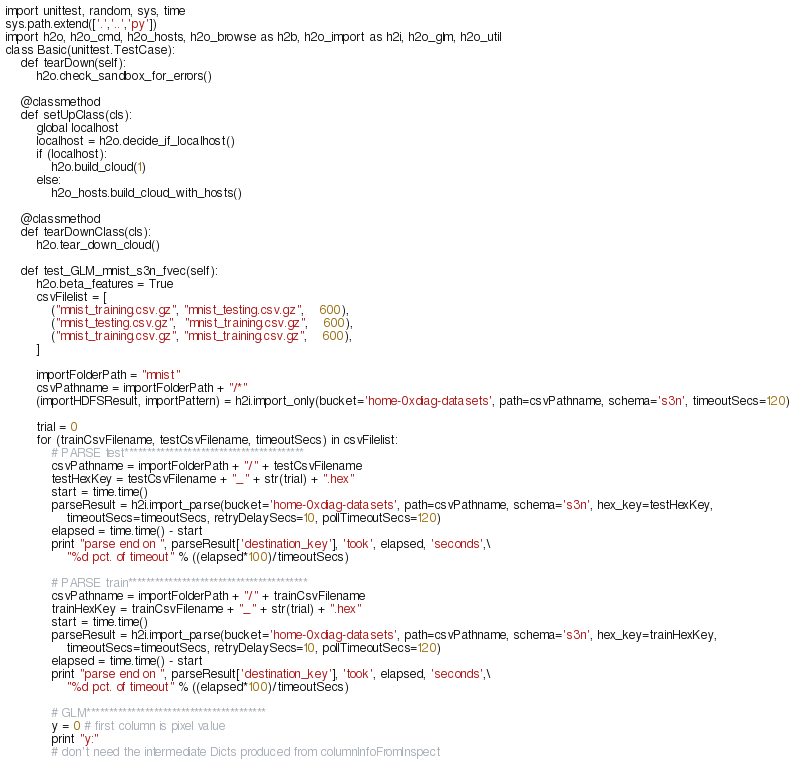Convert code to text. <code><loc_0><loc_0><loc_500><loc_500><_Python_>import unittest, random, sys, time
sys.path.extend(['.','..','py'])
import h2o, h2o_cmd, h2o_hosts, h2o_browse as h2b, h2o_import as h2i, h2o_glm, h2o_util
class Basic(unittest.TestCase):
    def tearDown(self):
        h2o.check_sandbox_for_errors()

    @classmethod
    def setUpClass(cls):
        global localhost
        localhost = h2o.decide_if_localhost()
        if (localhost):
            h2o.build_cloud(1)
        else:
            h2o_hosts.build_cloud_with_hosts()

    @classmethod
    def tearDownClass(cls):
        h2o.tear_down_cloud()

    def test_GLM_mnist_s3n_fvec(self):
        h2o.beta_features = True
        csvFilelist = [
            ("mnist_training.csv.gz", "mnist_testing.csv.gz",    600), 
            ("mnist_testing.csv.gz",  "mnist_training.csv.gz",    600), 
            ("mnist_training.csv.gz", "mnist_training.csv.gz",    600), 
        ]

        importFolderPath = "mnist"
        csvPathname = importFolderPath + "/*"
        (importHDFSResult, importPattern) = h2i.import_only(bucket='home-0xdiag-datasets', path=csvPathname, schema='s3n', timeoutSecs=120)

        trial = 0
        for (trainCsvFilename, testCsvFilename, timeoutSecs) in csvFilelist:
            # PARSE test****************************************
            csvPathname = importFolderPath + "/" + testCsvFilename
            testHexKey = testCsvFilename + "_" + str(trial) + ".hex"
            start = time.time()
            parseResult = h2i.import_parse(bucket='home-0xdiag-datasets', path=csvPathname, schema='s3n', hex_key=testHexKey,
                timeoutSecs=timeoutSecs, retryDelaySecs=10, pollTimeoutSecs=120)
            elapsed = time.time() - start
            print "parse end on ", parseResult['destination_key'], 'took', elapsed, 'seconds',\
                "%d pct. of timeout" % ((elapsed*100)/timeoutSecs)

            # PARSE train****************************************
            csvPathname = importFolderPath + "/" + trainCsvFilename
            trainHexKey = trainCsvFilename + "_" + str(trial) + ".hex"
            start = time.time()
            parseResult = h2i.import_parse(bucket='home-0xdiag-datasets', path=csvPathname, schema='s3n', hex_key=trainHexKey,
                timeoutSecs=timeoutSecs, retryDelaySecs=10, pollTimeoutSecs=120)
            elapsed = time.time() - start
            print "parse end on ", parseResult['destination_key'], 'took', elapsed, 'seconds',\
                "%d pct. of timeout" % ((elapsed*100)/timeoutSecs)

            # GLM****************************************
            y = 0 # first column is pixel value
            print "y:"
            # don't need the intermediate Dicts produced from columnInfoFromInspect</code> 